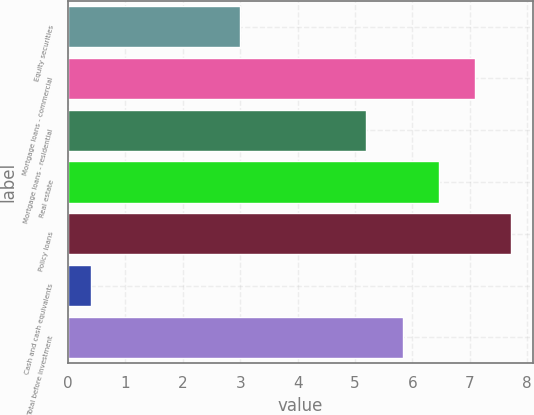<chart> <loc_0><loc_0><loc_500><loc_500><bar_chart><fcel>Equity securities<fcel>Mortgage loans - commercial<fcel>Mortgage loans - residential<fcel>Real estate<fcel>Policy loans<fcel>Cash and cash equivalents<fcel>Total before investment<nl><fcel>3<fcel>7.09<fcel>5.2<fcel>6.46<fcel>7.72<fcel>0.4<fcel>5.83<nl></chart> 